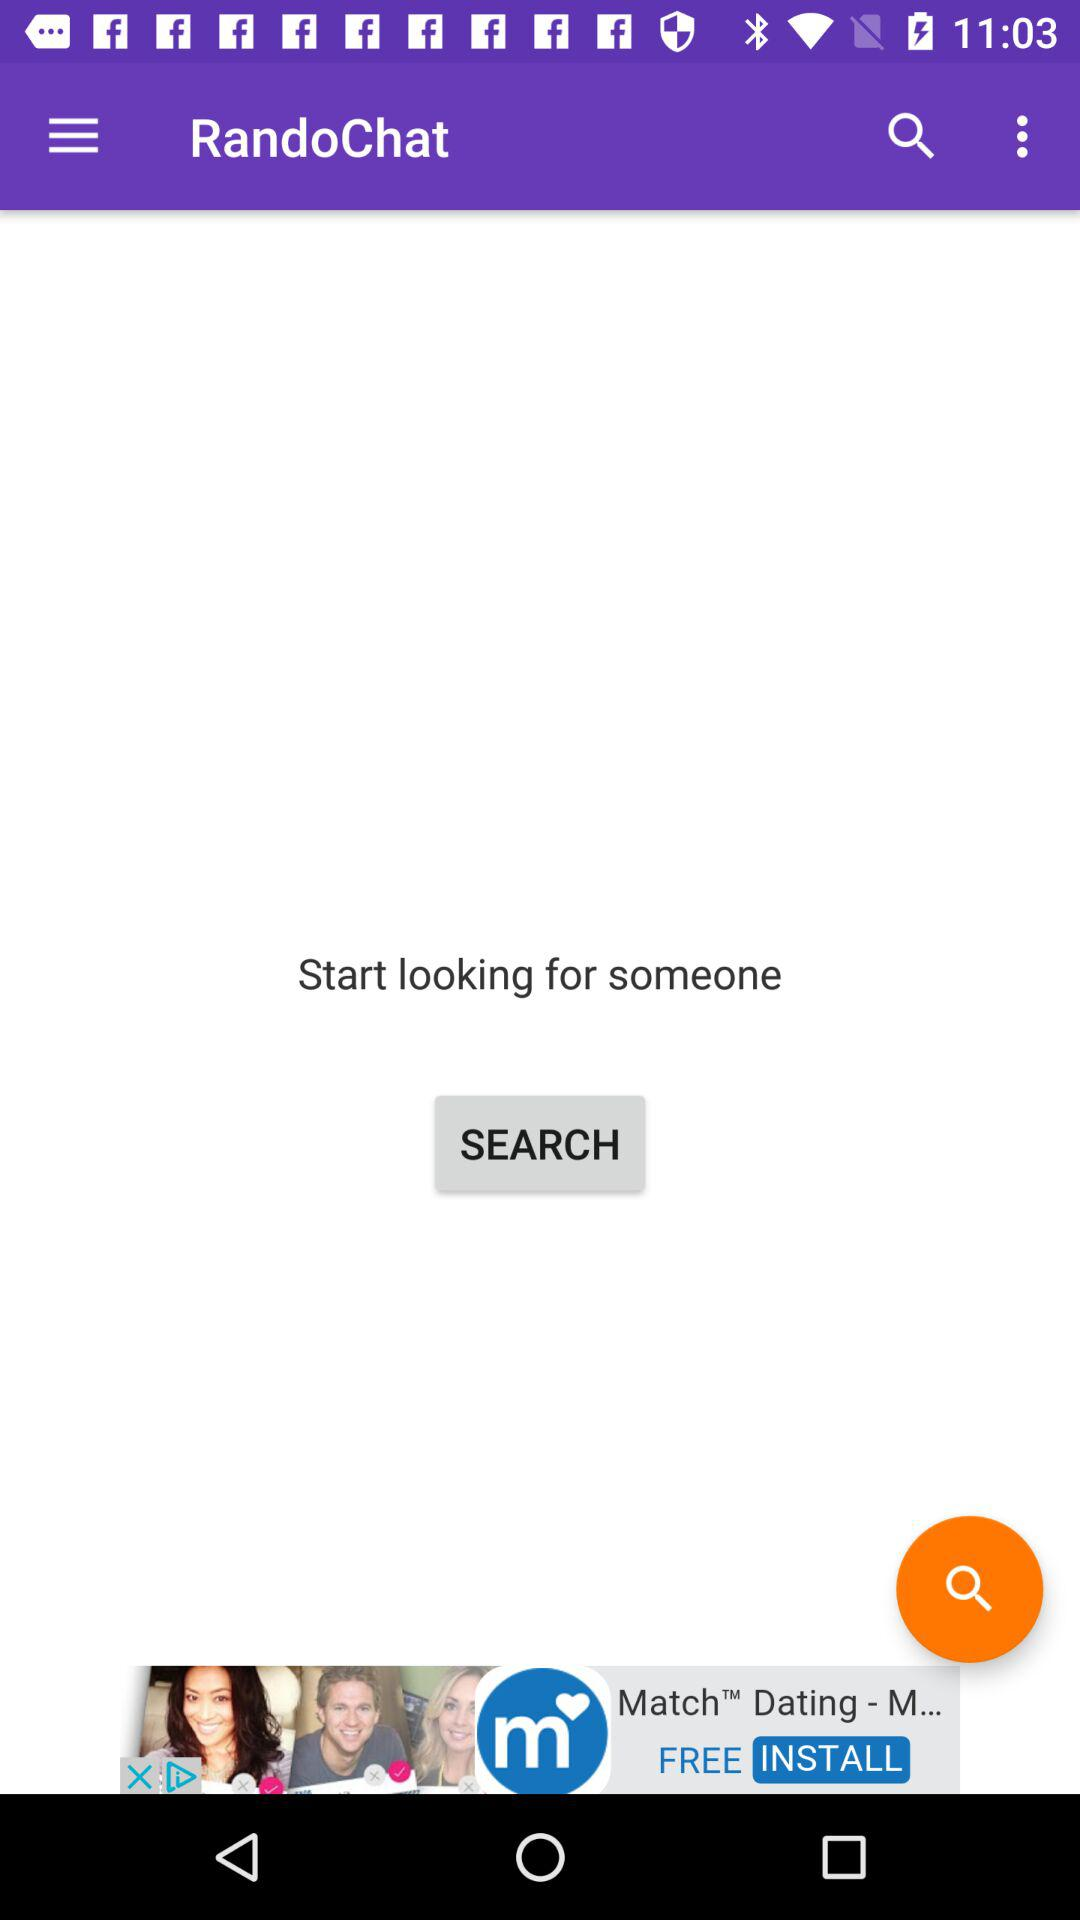What is the name of the application? The name of the application is "RandoChat". 